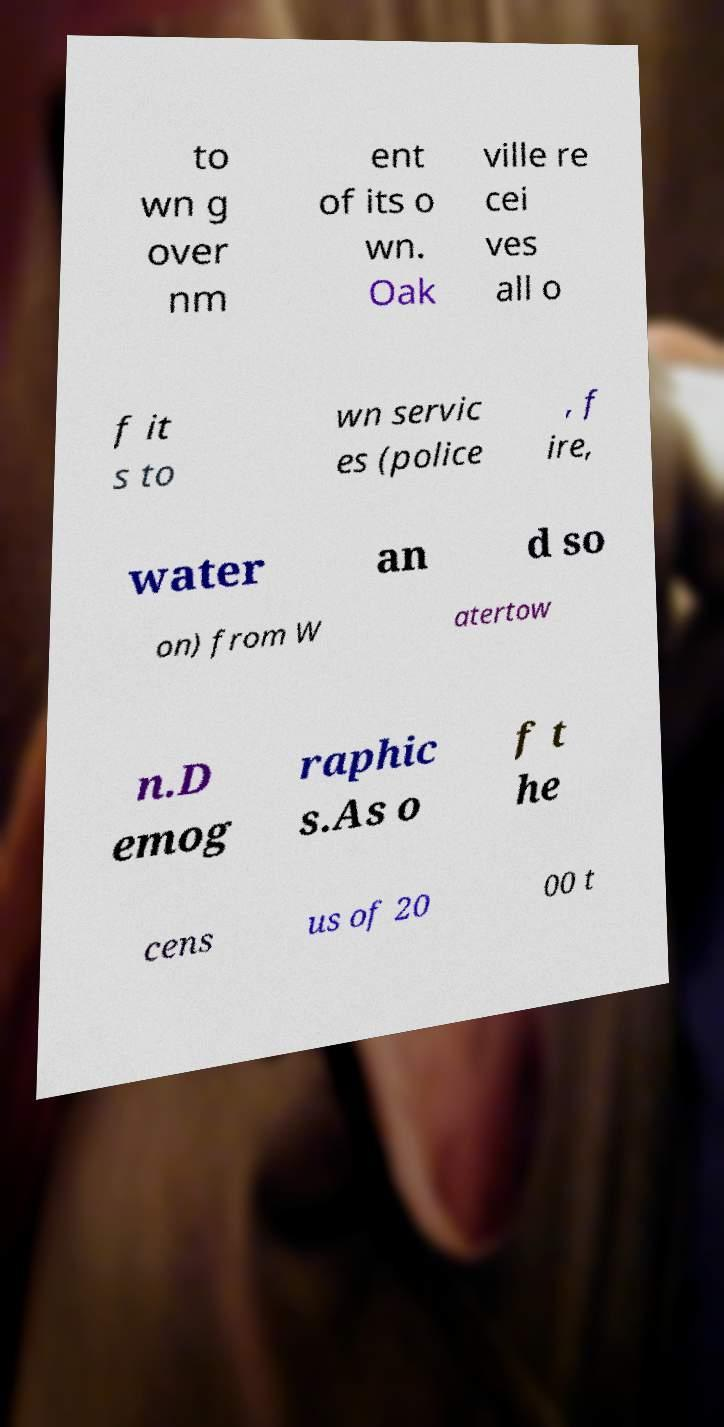What messages or text are displayed in this image? I need them in a readable, typed format. to wn g over nm ent of its o wn. Oak ville re cei ves all o f it s to wn servic es (police , f ire, water an d so on) from W atertow n.D emog raphic s.As o f t he cens us of 20 00 t 